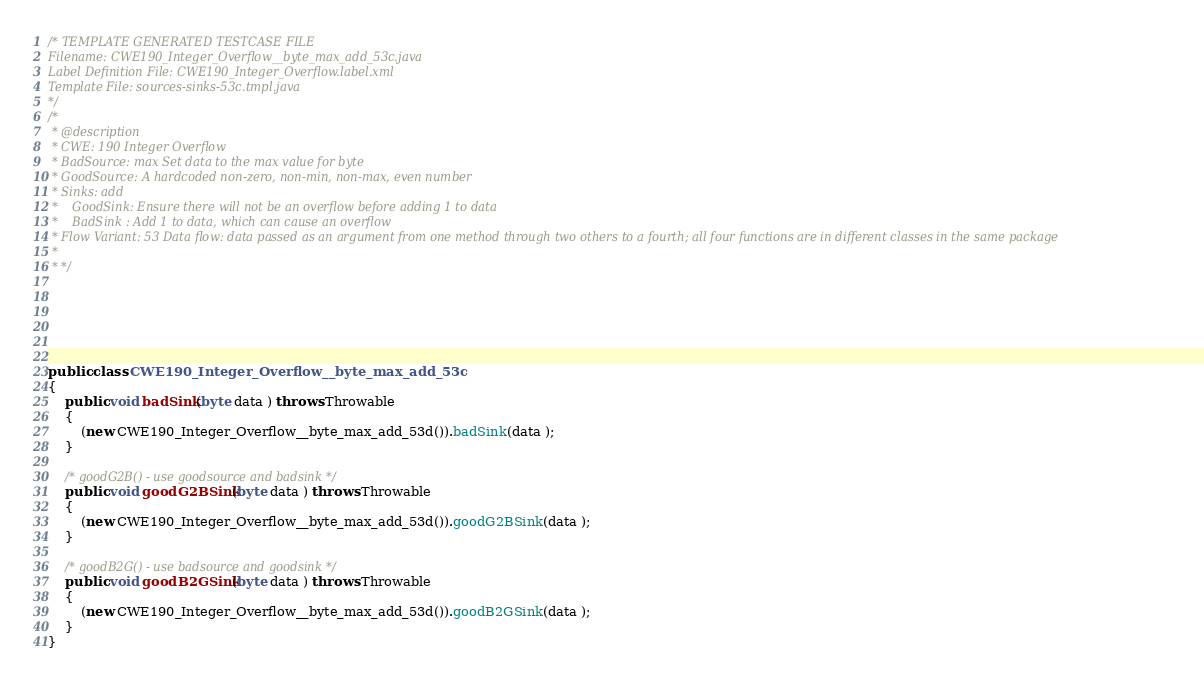<code> <loc_0><loc_0><loc_500><loc_500><_Java_>/* TEMPLATE GENERATED TESTCASE FILE
Filename: CWE190_Integer_Overflow__byte_max_add_53c.java
Label Definition File: CWE190_Integer_Overflow.label.xml
Template File: sources-sinks-53c.tmpl.java
*/
/*
 * @description
 * CWE: 190 Integer Overflow
 * BadSource: max Set data to the max value for byte
 * GoodSource: A hardcoded non-zero, non-min, non-max, even number
 * Sinks: add
 *    GoodSink: Ensure there will not be an overflow before adding 1 to data
 *    BadSink : Add 1 to data, which can cause an overflow
 * Flow Variant: 53 Data flow: data passed as an argument from one method through two others to a fourth; all four functions are in different classes in the same package
 *
 * */






public class CWE190_Integer_Overflow__byte_max_add_53c
{
    public void badSink(byte data ) throws Throwable
    {
        (new CWE190_Integer_Overflow__byte_max_add_53d()).badSink(data );
    }

    /* goodG2B() - use goodsource and badsink */
    public void goodG2BSink(byte data ) throws Throwable
    {
        (new CWE190_Integer_Overflow__byte_max_add_53d()).goodG2BSink(data );
    }

    /* goodB2G() - use badsource and goodsink */
    public void goodB2GSink(byte data ) throws Throwable
    {
        (new CWE190_Integer_Overflow__byte_max_add_53d()).goodB2GSink(data );
    }
}
</code> 